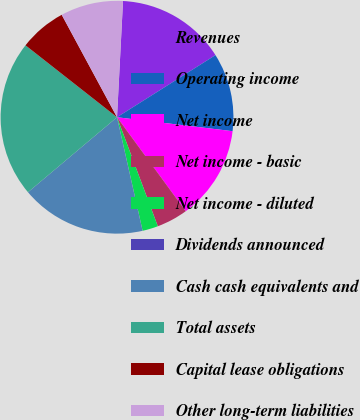Convert chart. <chart><loc_0><loc_0><loc_500><loc_500><pie_chart><fcel>Revenues<fcel>Operating income<fcel>Net income<fcel>Net income - basic<fcel>Net income - diluted<fcel>Dividends announced<fcel>Cash cash equivalents and<fcel>Total assets<fcel>Capital lease obligations<fcel>Other long-term liabilities<nl><fcel>15.22%<fcel>10.87%<fcel>13.04%<fcel>4.35%<fcel>2.17%<fcel>0.0%<fcel>17.39%<fcel>21.74%<fcel>6.52%<fcel>8.7%<nl></chart> 